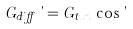<formula> <loc_0><loc_0><loc_500><loc_500>G _ { d i f f } \, \theta = G _ { t u n } \, \cos \theta</formula> 